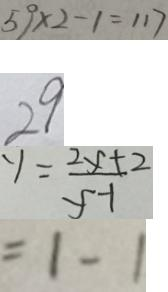<formula> <loc_0><loc_0><loc_500><loc_500>5 9 \times 2 - 1 = 1 1 7 
 2 9 
 y = \frac { 2 y + 2 } { y - 1 } 
 = 1 - 1</formula> 